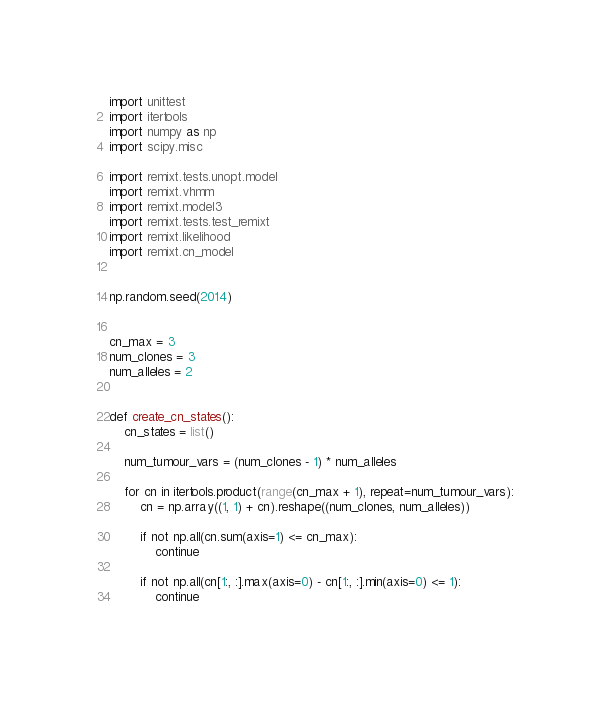<code> <loc_0><loc_0><loc_500><loc_500><_Python_>import unittest
import itertools
import numpy as np
import scipy.misc

import remixt.tests.unopt.model
import remixt.vhmm
import remixt.model3
import remixt.tests.test_remixt
import remixt.likelihood
import remixt.cn_model


np.random.seed(2014)


cn_max = 3
num_clones = 3
num_alleles = 2


def create_cn_states():
    cn_states = list()

    num_tumour_vars = (num_clones - 1) * num_alleles

    for cn in itertools.product(range(cn_max + 1), repeat=num_tumour_vars):
        cn = np.array((1, 1) + cn).reshape((num_clones, num_alleles))

        if not np.all(cn.sum(axis=1) <= cn_max):
            continue

        if not np.all(cn[1:, :].max(axis=0) - cn[1:, :].min(axis=0) <= 1):
            continue
</code> 